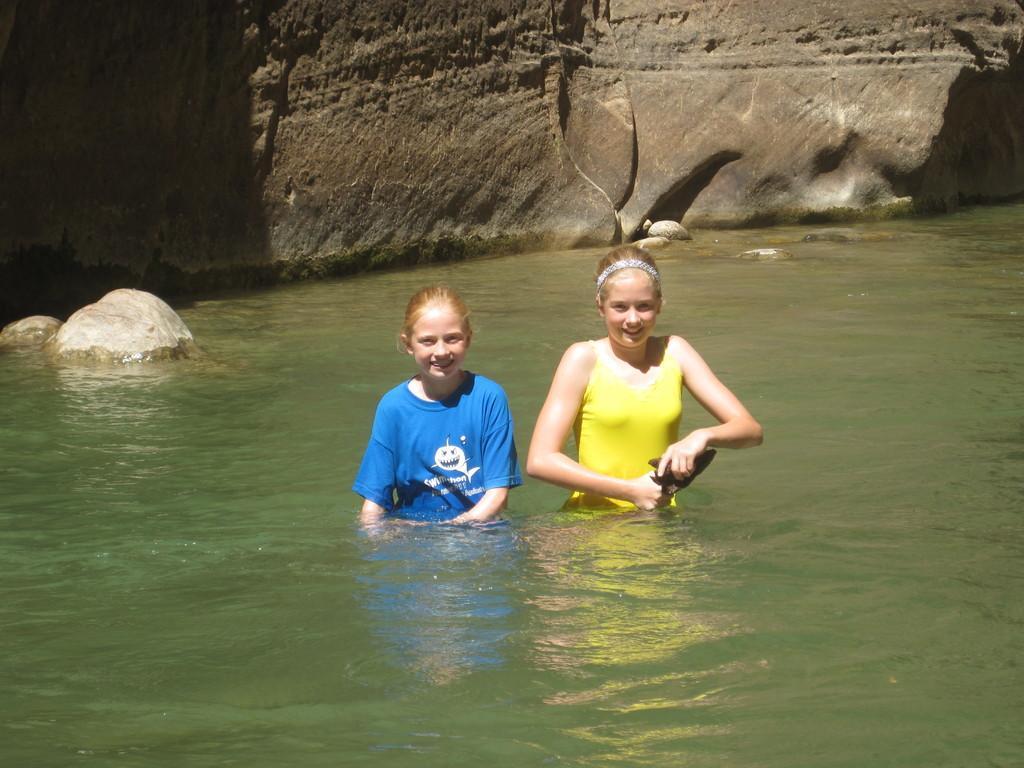How would you summarize this image in a sentence or two? In this picture we can see two people are standing in the water and holding an object, behind we can see some big rocks. 